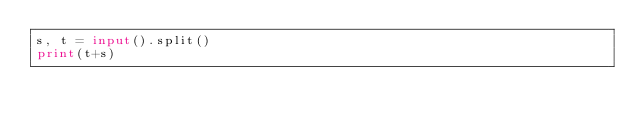Convert code to text. <code><loc_0><loc_0><loc_500><loc_500><_Python_>s, t = input().split()
print(t+s)</code> 